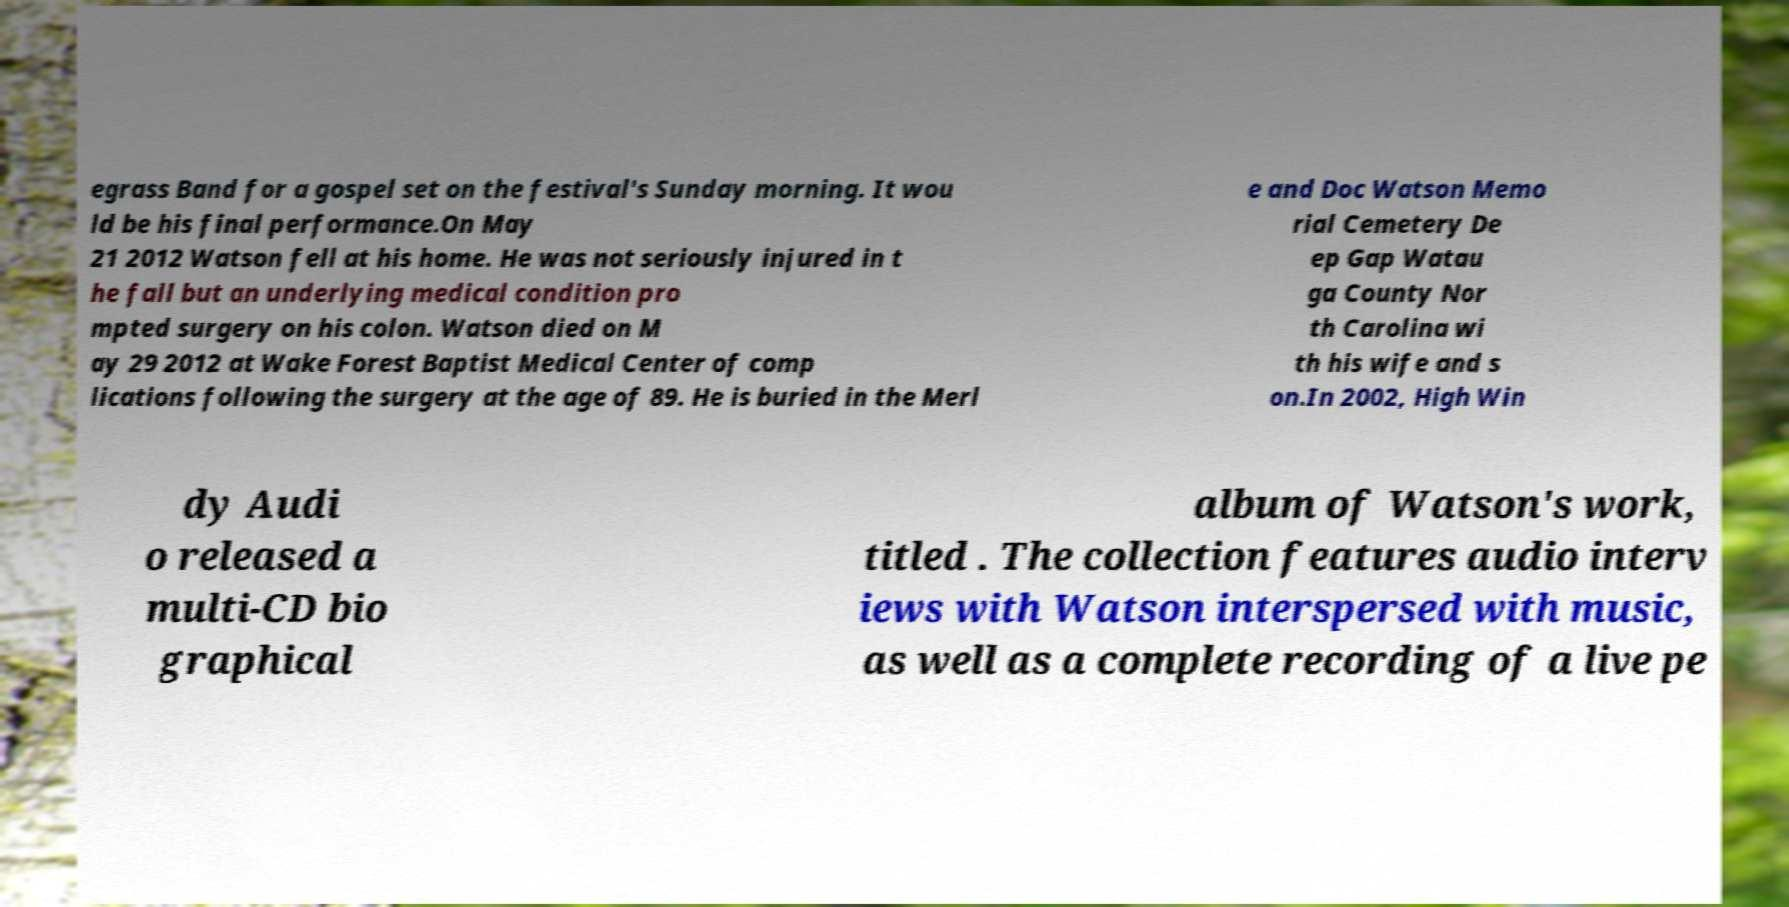Can you accurately transcribe the text from the provided image for me? egrass Band for a gospel set on the festival's Sunday morning. It wou ld be his final performance.On May 21 2012 Watson fell at his home. He was not seriously injured in t he fall but an underlying medical condition pro mpted surgery on his colon. Watson died on M ay 29 2012 at Wake Forest Baptist Medical Center of comp lications following the surgery at the age of 89. He is buried in the Merl e and Doc Watson Memo rial Cemetery De ep Gap Watau ga County Nor th Carolina wi th his wife and s on.In 2002, High Win dy Audi o released a multi-CD bio graphical album of Watson's work, titled . The collection features audio interv iews with Watson interspersed with music, as well as a complete recording of a live pe 